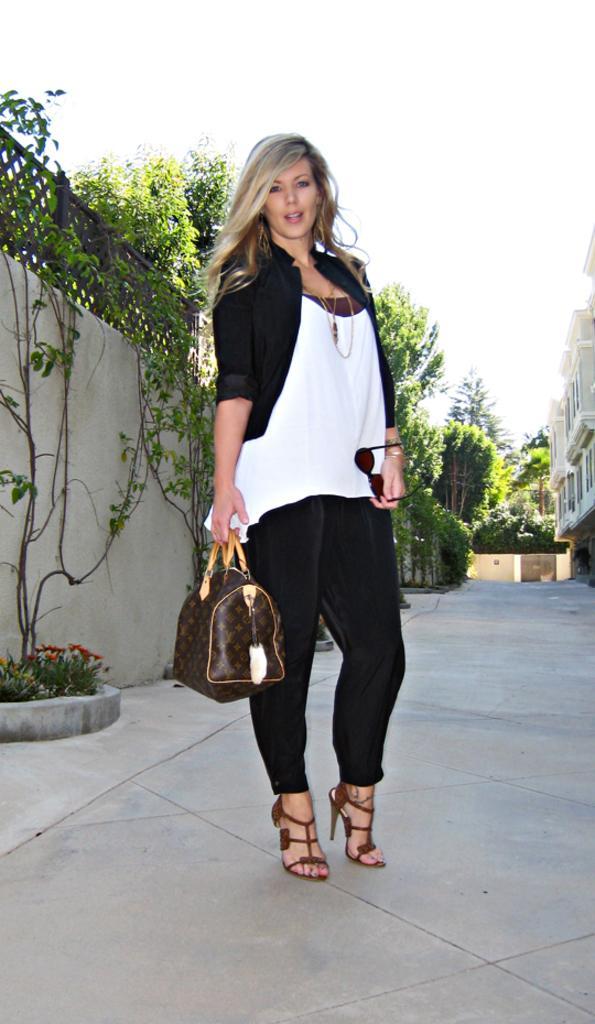Could you give a brief overview of what you see in this image? In the picture we can find one woman standing on the path. In the background we can find plants, wall, sky, and some trees. She is holding a handbag. 